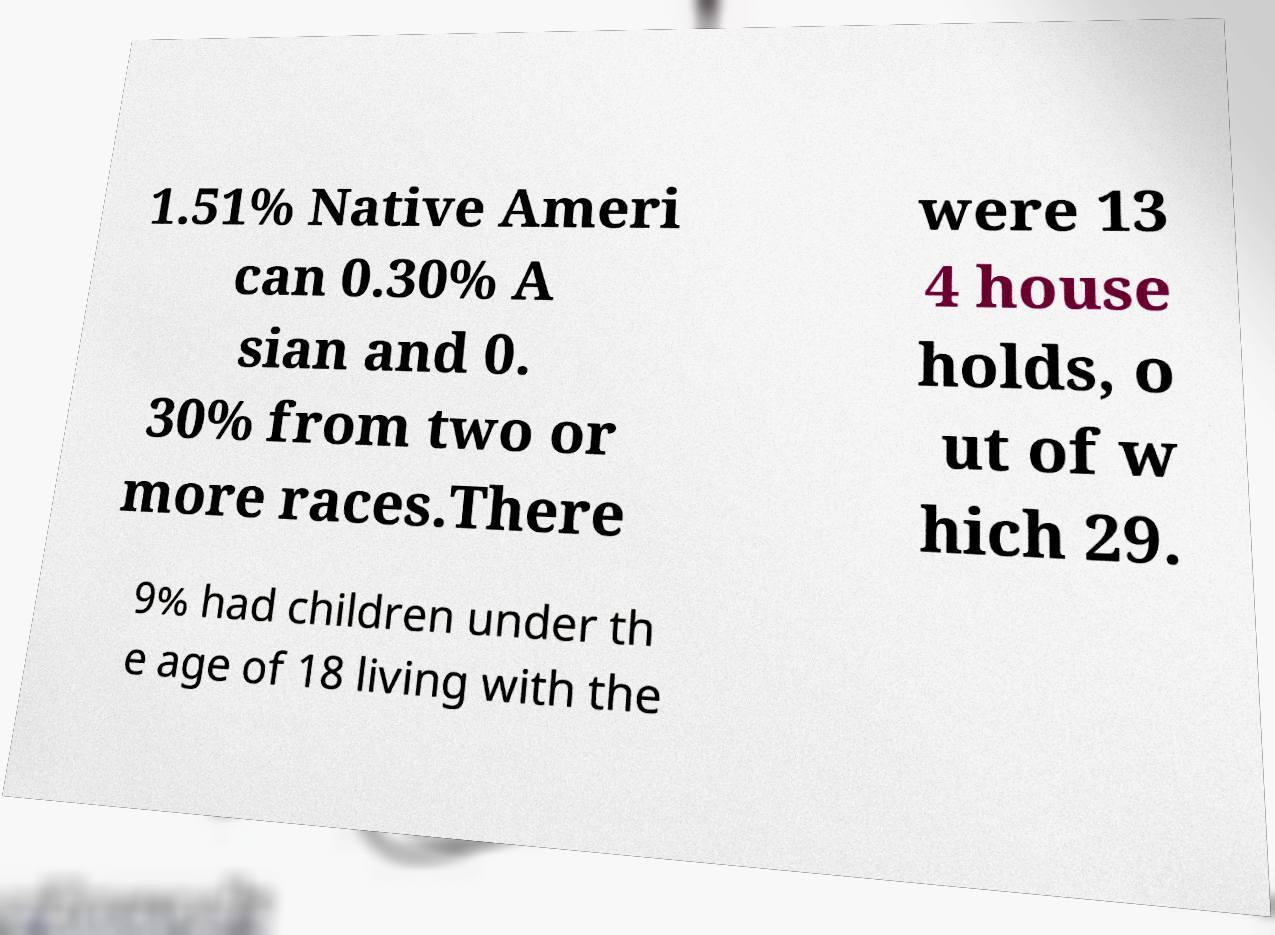Please read and relay the text visible in this image. What does it say? 1.51% Native Ameri can 0.30% A sian and 0. 30% from two or more races.There were 13 4 house holds, o ut of w hich 29. 9% had children under th e age of 18 living with the 